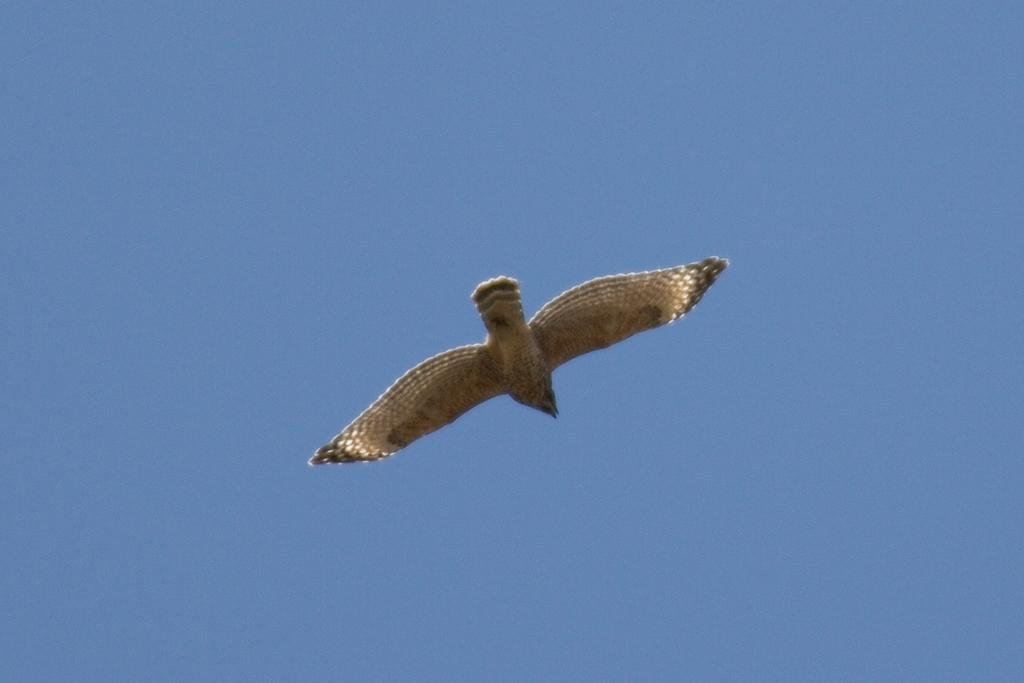What type of animal is present in the image? There is a bird in the image. What is the bird doing in the image? The bird is flying in the air. What can be seen in the background of the image? The sky is visible in the background of the image. What is the color of the sky in the image? The color of the sky is blue. How many brushes are used to paint the bird in the image? There are no brushes or painting involved in the image; it is a photograph of a bird flying in the sky. 